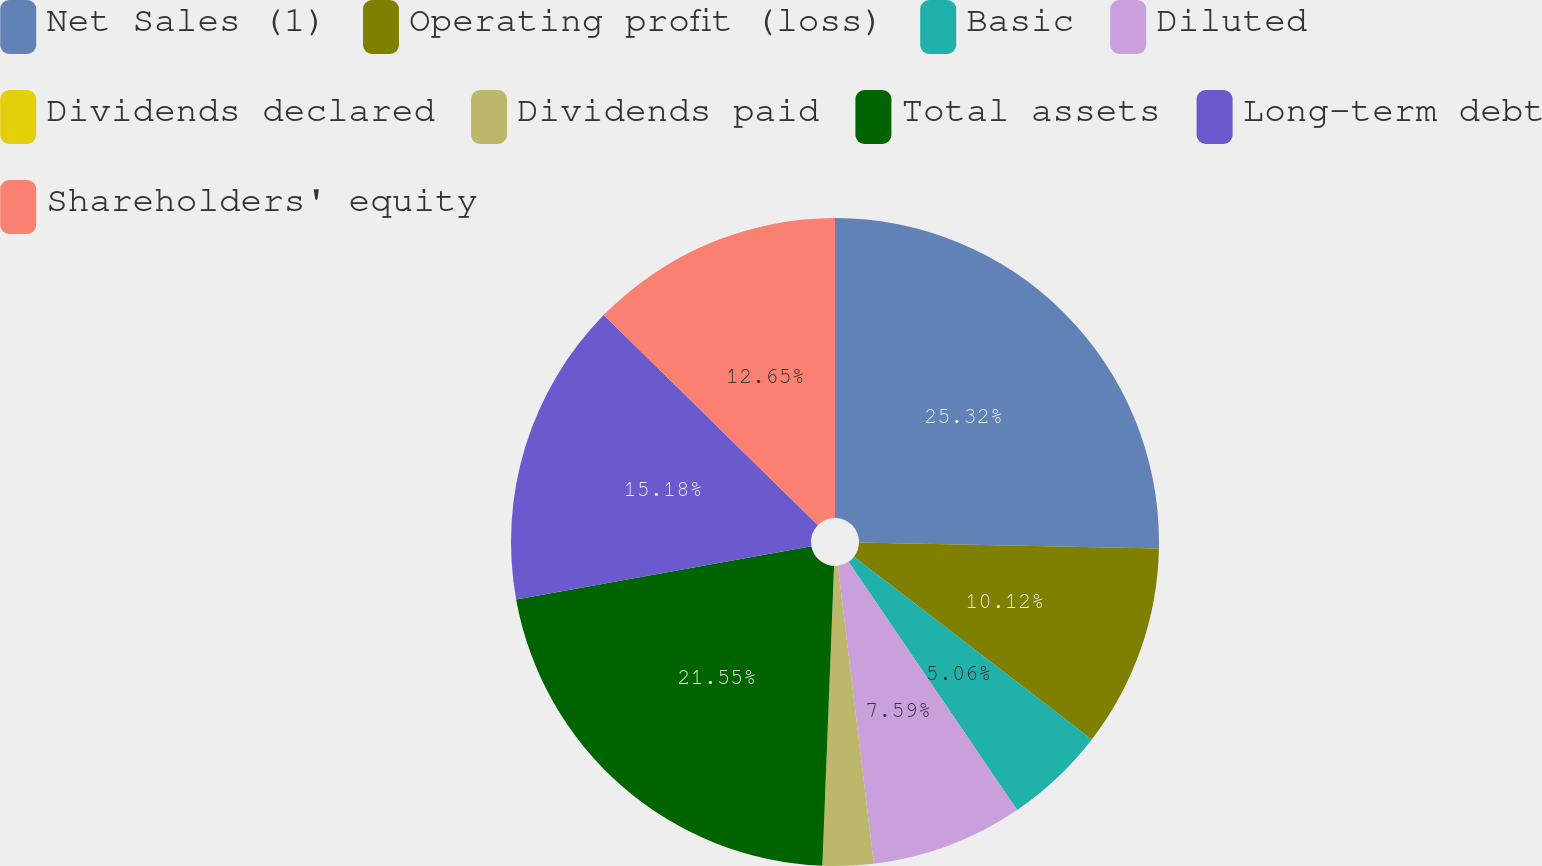Convert chart to OTSL. <chart><loc_0><loc_0><loc_500><loc_500><pie_chart><fcel>Net Sales (1)<fcel>Operating profit (loss)<fcel>Basic<fcel>Diluted<fcel>Dividends declared<fcel>Dividends paid<fcel>Total assets<fcel>Long-term debt<fcel>Shareholders' equity<nl><fcel>25.31%<fcel>10.12%<fcel>5.06%<fcel>7.59%<fcel>0.0%<fcel>2.53%<fcel>21.54%<fcel>15.18%<fcel>12.65%<nl></chart> 